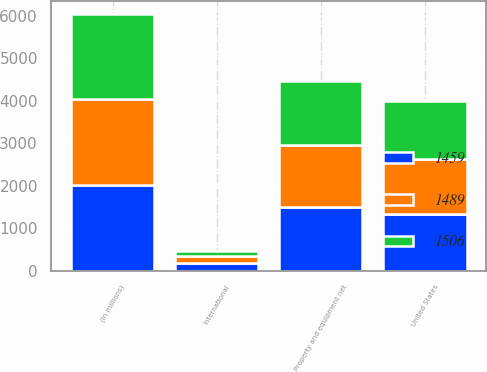Convert chart to OTSL. <chart><loc_0><loc_0><loc_500><loc_500><stacked_bar_chart><ecel><fcel>(in millions)<fcel>United States<fcel>International<fcel>Property and equipment net<nl><fcel>1459<fcel>2015<fcel>1327<fcel>179<fcel>1506<nl><fcel>1489<fcel>2014<fcel>1301<fcel>158<fcel>1459<nl><fcel>1506<fcel>2013<fcel>1355<fcel>134<fcel>1489<nl></chart> 